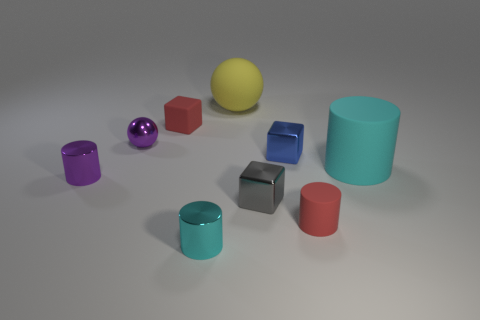Add 1 rubber cylinders. How many objects exist? 10 Subtract all cubes. How many objects are left? 6 Add 6 tiny purple metal objects. How many tiny purple metal objects are left? 8 Add 9 gray things. How many gray things exist? 10 Subtract 0 brown cylinders. How many objects are left? 9 Subtract all tiny red cylinders. Subtract all small red cubes. How many objects are left? 7 